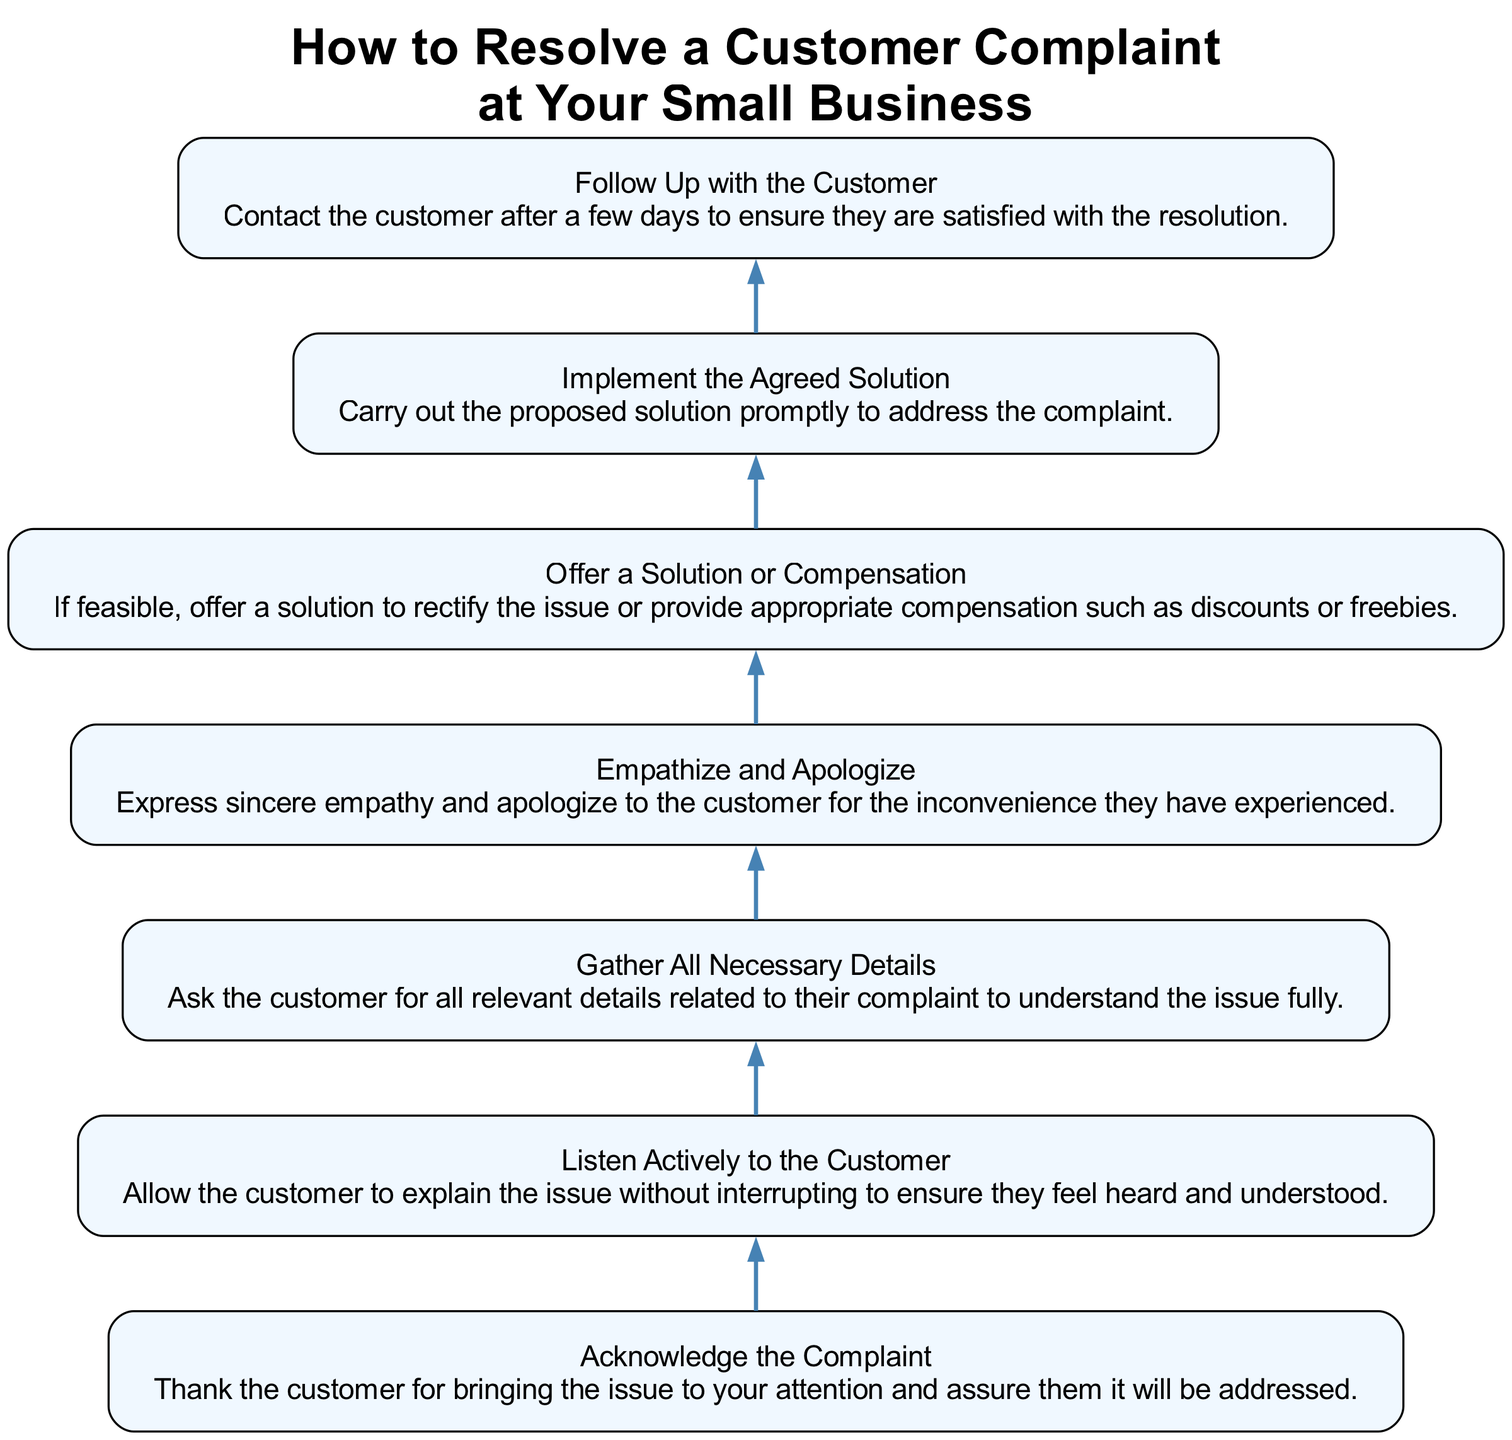What is the first step in the complaint resolution process? The diagram indicates that the first step is to acknowledge the complaint. This means thanking the customer for bringing the issue to attention and reassuring them it will be addressed.
Answer: Acknowledge the Complaint How many steps are shown in the diagram? The diagram lists seven distinct steps to resolve a customer complaint. These steps follow a sequential order from the bottom to the top of the flow chart.
Answer: Seven What is the last step in the process? The last step, which is located at the top of the diagram, is to follow up with the customer. This involves ensuring the customer is satisfied with the resolution a few days after the solution is implemented.
Answer: Follow Up with the Customer What step involves expressing empathy? According to the diagram, the step that involves expressing empathy is labeled "Empathize and Apologize." This step emphasizes understanding the customer's experience and offering a sincere apology for any inconvenience caused.
Answer: Empathize and Apologize At which step do you offer compensation? The diagram indicates that compensation is offered in the "Offer a Solution or Compensation" step. This step includes providing a solution to rectify the issue or giving appropriate compensation, such as discounts or freebies.
Answer: Offer a Solution or Compensation If a customer has complained, which steps must be completed before following up? In the workflow, the steps that must be completed before following up are: first, acknowledge the complaint, second, gather necessary details, third, listen actively to the customer, fourth, empathize and apologize, fifth, offer a solution or compensation, and sixth, implement the agreed solution. Therefore, six steps must be done before following up with the customer.
Answer: Six steps After implementing the solution, what should you do next? Following the implementation of the agreed solution, the next step, according to the diagram, is to follow up with the customer. This ensures they are satisfied with what has been done to address their concern.
Answer: Follow Up with the Customer 